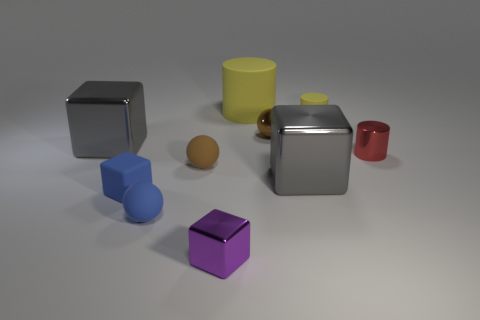Subtract all cubes. How many objects are left? 6 Add 7 small brown matte spheres. How many small brown matte spheres exist? 8 Subtract 0 blue cylinders. How many objects are left? 10 Subtract all purple shiny spheres. Subtract all brown things. How many objects are left? 8 Add 5 small brown balls. How many small brown balls are left? 7 